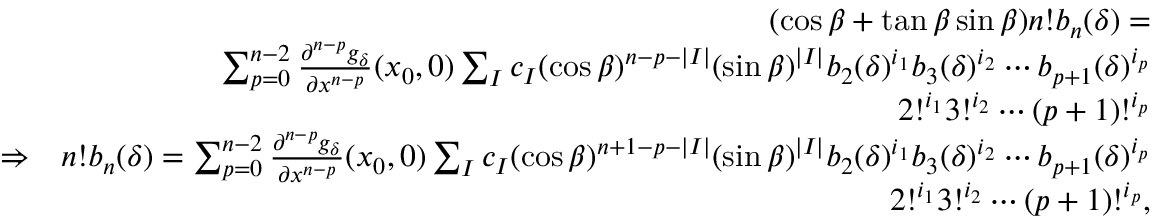Convert formula to latex. <formula><loc_0><loc_0><loc_500><loc_500>\begin{array} { r l r } & { ( \cos \beta + \tan \beta \sin \beta ) n ! b _ { n } ( \delta ) = } \\ & { \sum _ { p = 0 } ^ { n - 2 } \frac { \partial ^ { n - p } g _ { \delta } } { \partial x ^ { n - p } } ( x _ { 0 } , 0 ) \sum _ { I } c _ { I } ( \cos \beta ) ^ { n - p - | I | } ( \sin \beta ) ^ { | I | } b _ { 2 } ( \delta ) ^ { i _ { 1 } } b _ { 3 } ( \delta ) ^ { i _ { 2 } } \cdots b _ { p + 1 } ( \delta ) ^ { i _ { p } } } \\ & { 2 ! ^ { i _ { 1 } } 3 ! ^ { i _ { 2 } } \cdots ( p + 1 ) ! ^ { i _ { p } } } \\ & { \Rightarrow } & { n ! b _ { n } ( \delta ) = \sum _ { p = 0 } ^ { n - 2 } \frac { \partial ^ { n - p } g _ { \delta } } { \partial x ^ { n - p } } ( x _ { 0 } , 0 ) \sum _ { I } c _ { I } ( \cos \beta ) ^ { n + 1 - p - | I | } ( \sin \beta ) ^ { | I | } b _ { 2 } ( \delta ) ^ { i _ { 1 } } b _ { 3 } ( \delta ) ^ { i _ { 2 } } \cdots b _ { p + 1 } ( \delta ) ^ { i _ { p } } } \\ & { 2 ! ^ { i _ { 1 } } 3 ! ^ { i _ { 2 } } \cdots ( p + 1 ) ! ^ { i _ { p } } , } \end{array}</formula> 